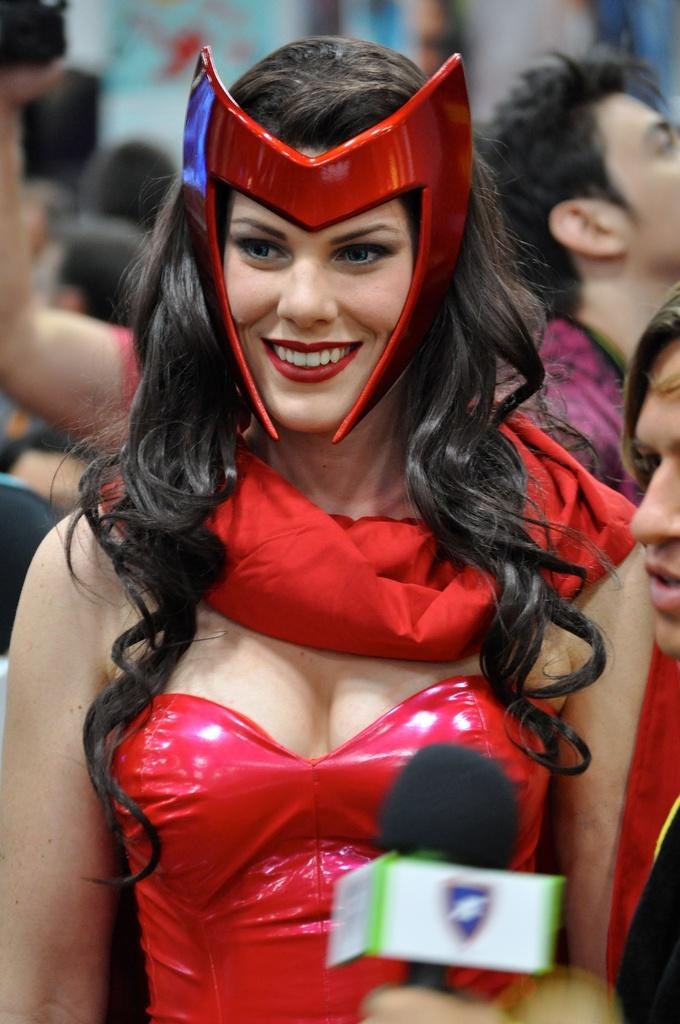What can be seen in the image? There is a group of people in the image. Can you describe the woman standing in the front? The woman standing in the front is wearing a red dress. What is the woman holding? The woman is holding a microphone. How would you describe the background of the image? The background of the image is slightly blurred. What type of drum is being played by the woman in the image? There is no drum present in the image; the woman is holding a microphone. Can you solve the riddle that is being told by the woman in the image? There is no riddle being told in the image; the woman is holding a microphone. 